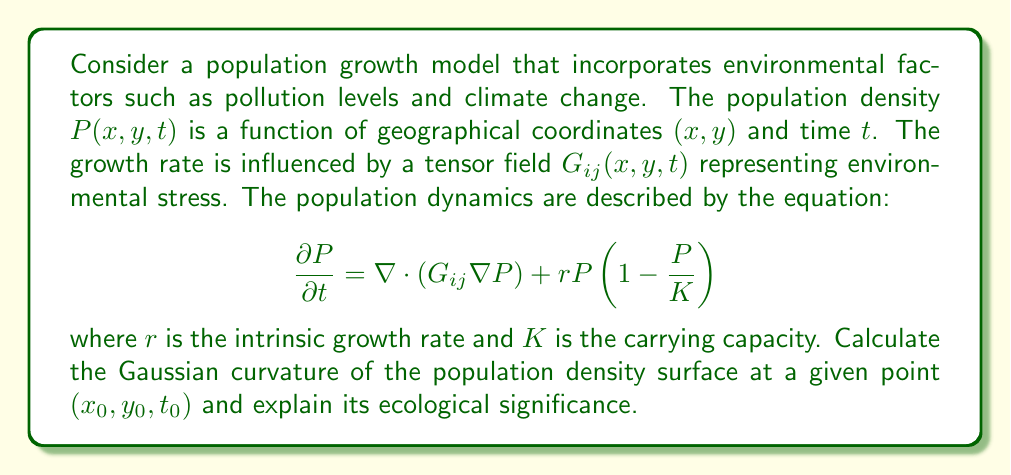Provide a solution to this math problem. To solve this problem, we'll follow these steps:

1) First, we need to understand that the Gaussian curvature of a surface $z = f(x, y)$ at a point is given by:

   $$K = \frac{f_{xx}f_{yy} - f_{xy}^2}{(1 + f_x^2 + f_y^2)^2}$$

   where subscripts denote partial derivatives.

2) In our case, $f(x, y) = P(x, y, t_0)$ at a fixed time $t_0$.

3) We need to calculate $f_{xx}$, $f_{yy}$, and $f_{xy}$. These are second-order partial derivatives of $P$ with respect to $x$ and $y$.

4) From the given equation, we can derive:

   $$\frac{\partial P}{\partial x} = \frac{\partial}{\partial x}(G_{11}\frac{\partial P}{\partial x} + G_{12}\frac{\partial P}{\partial y}) + \frac{\partial}{\partial y}(G_{21}\frac{\partial P}{\partial x} + G_{22}\frac{\partial P}{\partial y})$$

   $$\frac{\partial P}{\partial y} = \frac{\partial}{\partial x}(G_{12}\frac{\partial P}{\partial x} + G_{22}\frac{\partial P}{\partial y}) + \frac{\partial}{\partial y}(G_{21}\frac{\partial P}{\partial x} + G_{22}\frac{\partial P}{\partial y})$$

5) Taking second derivatives:

   $$f_{xx} = \frac{\partial^2 P}{\partial x^2} = \frac{\partial}{\partial x}(\frac{\partial P}{\partial x})$$
   $$f_{yy} = \frac{\partial^2 P}{\partial y^2} = \frac{\partial}{\partial y}(\frac{\partial P}{\partial y})$$
   $$f_{xy} = \frac{\partial^2 P}{\partial x \partial y} = \frac{\partial}{\partial y}(\frac{\partial P}{\partial x})$$

6) Substitute these values into the Gaussian curvature formula:

   $$K = \frac{f_{xx}f_{yy} - f_{xy}^2}{(1 + (\frac{\partial P}{\partial x})^2 + (\frac{\partial P}{\partial y})^2)^2}$$

7) The ecological significance of the Gaussian curvature:
   - Positive curvature indicates a local peak or valley in population density.
   - Negative curvature suggests a saddle point, where the population is increasing in one direction and decreasing in another.
   - Zero curvature implies a flat or cylindrical surface, indicating uniform growth or decline in at least one direction.

8) The curvature is influenced by the environmental stress tensor $G_{ij}$, reflecting how pollution and climate change affect population distribution and growth patterns.
Answer: $$K = \frac{f_{xx}f_{yy} - f_{xy}^2}{(1 + (\frac{\partial P}{\partial x})^2 + (\frac{\partial P}{\partial y})^2)^2}$$ 